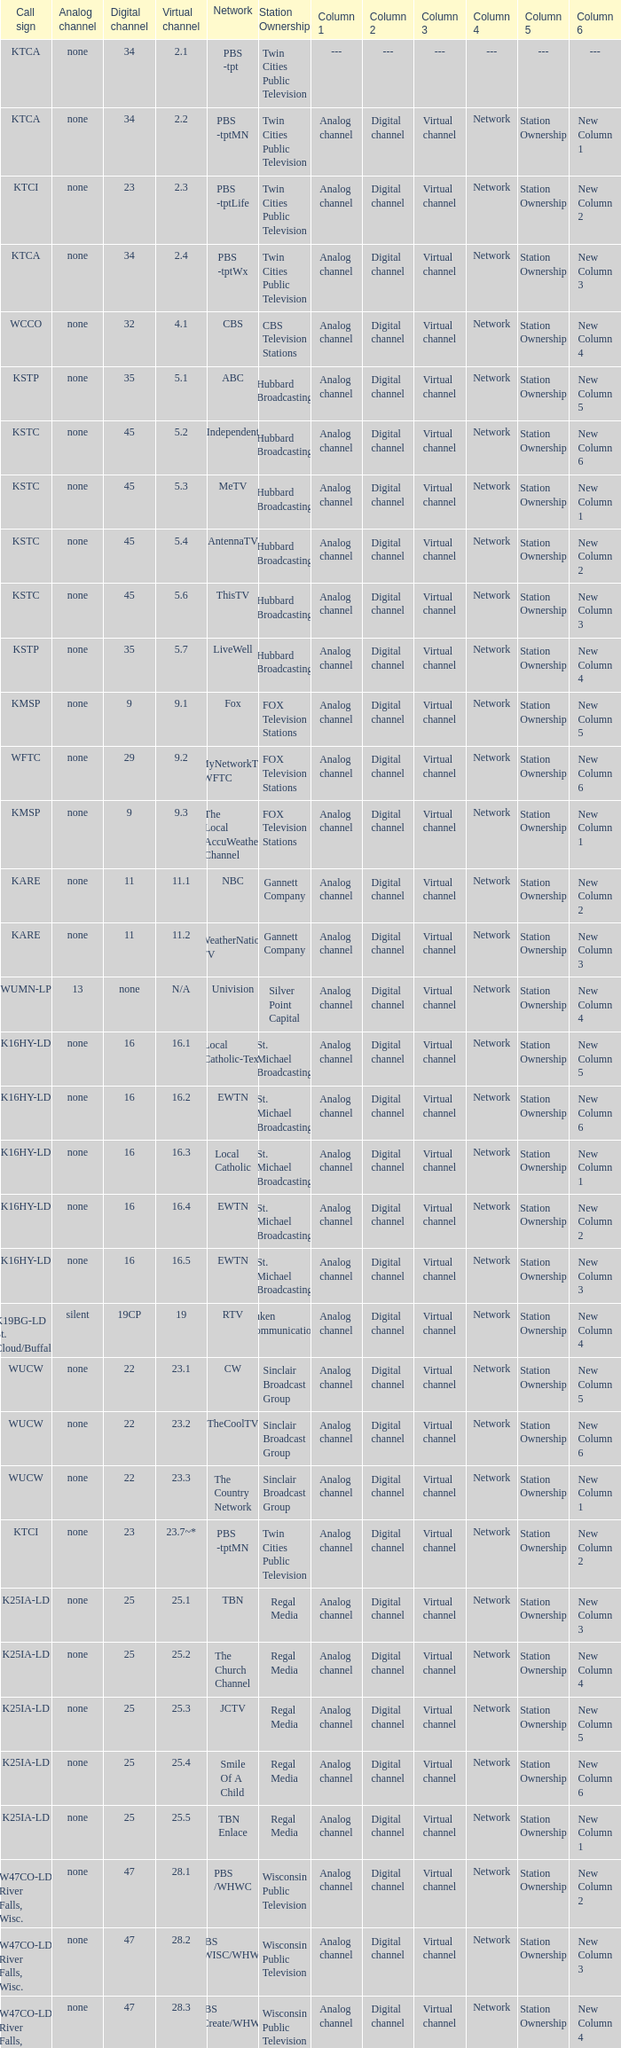Call sign of k33ln-ld, and a Virtual channel of 33.5 is what network? 3ABN Radio-Audio. 